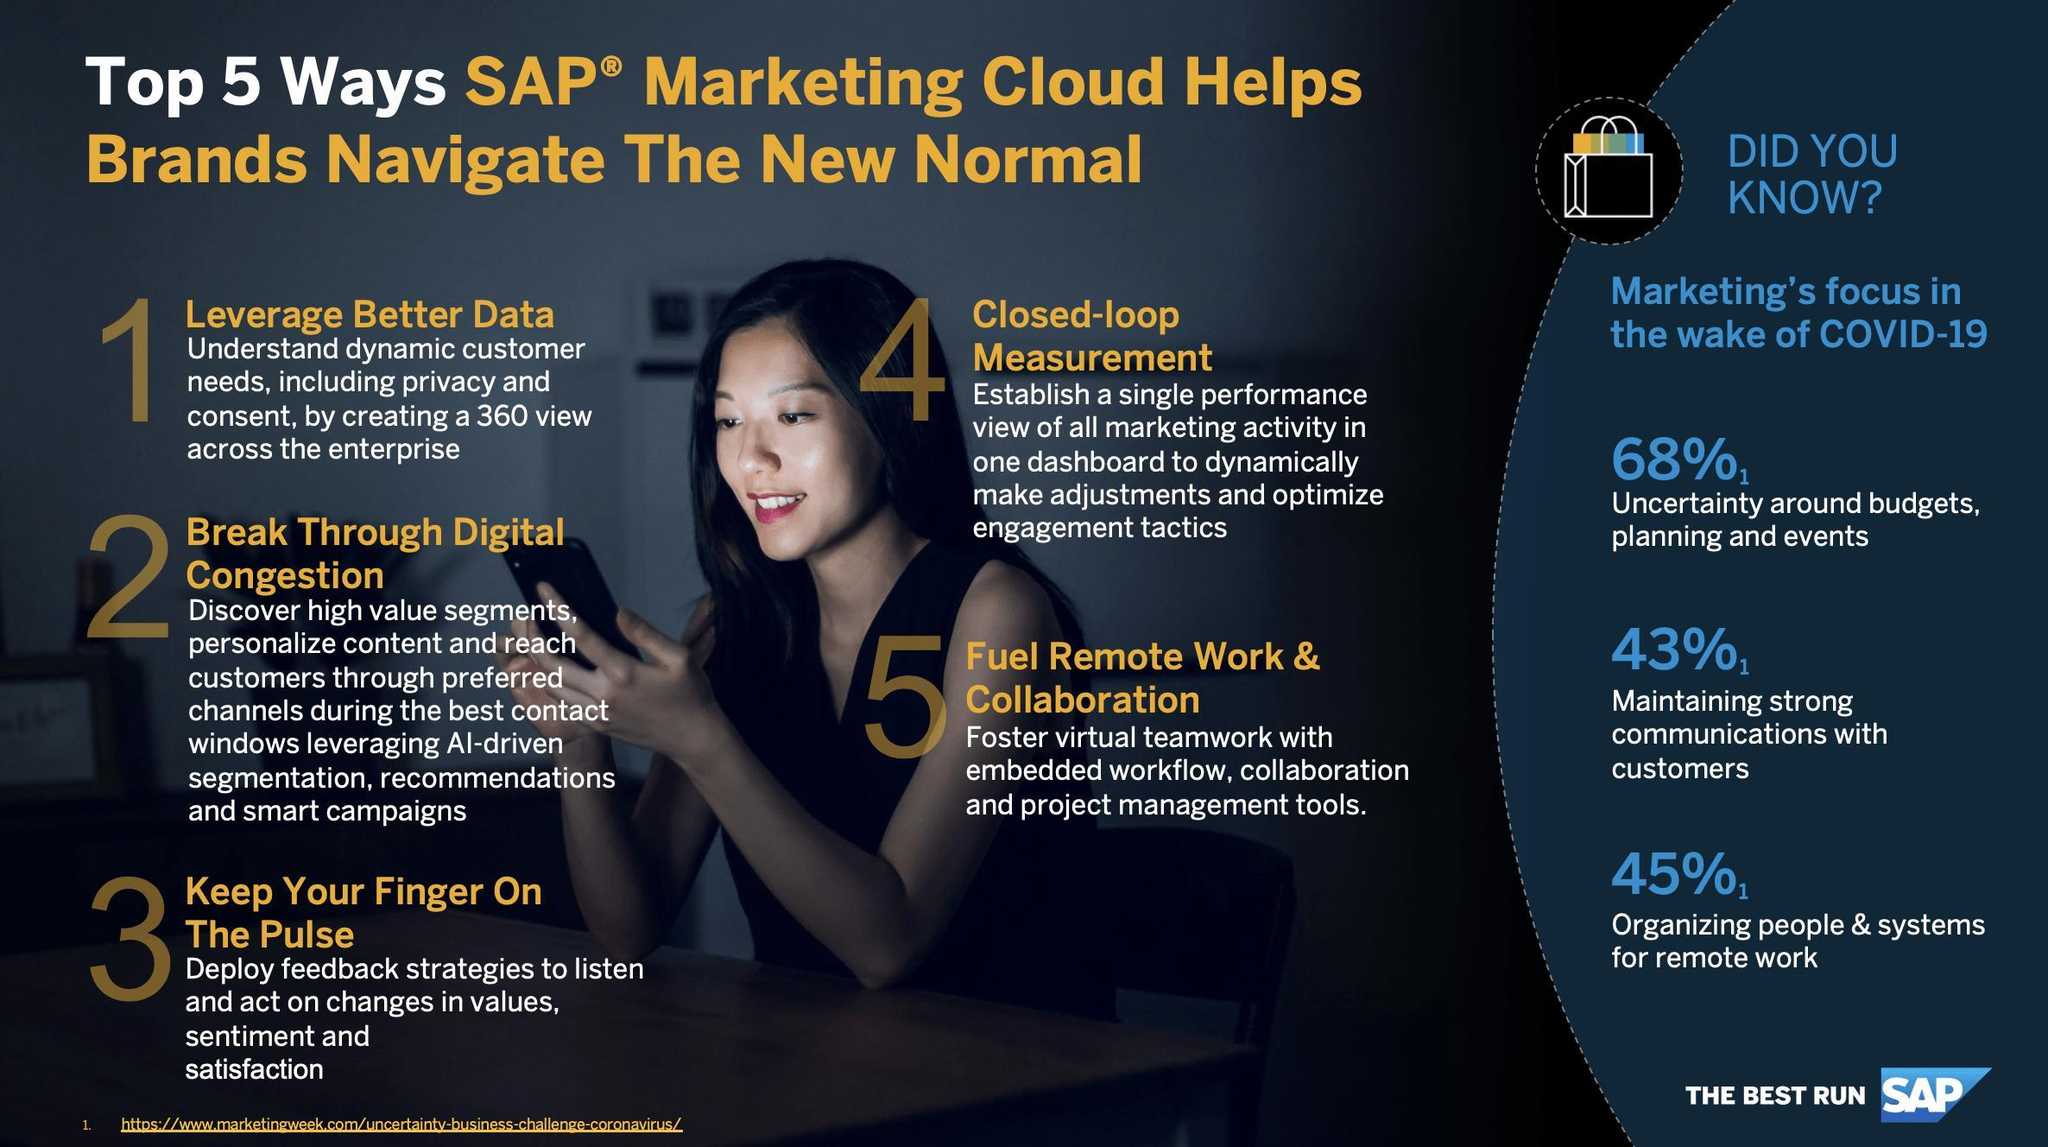What percentage of problems related with keeping line with customers interest are solved by SAP?
Answer the question with a short phrase. 43% 